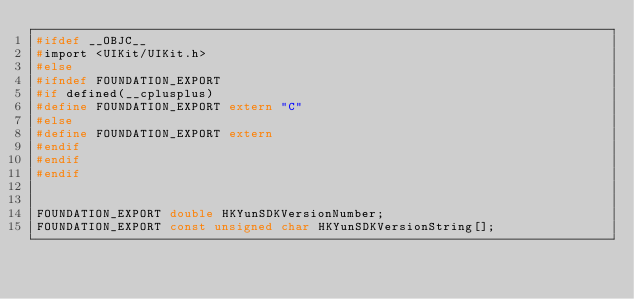Convert code to text. <code><loc_0><loc_0><loc_500><loc_500><_C_>#ifdef __OBJC__
#import <UIKit/UIKit.h>
#else
#ifndef FOUNDATION_EXPORT
#if defined(__cplusplus)
#define FOUNDATION_EXPORT extern "C"
#else
#define FOUNDATION_EXPORT extern
#endif
#endif
#endif


FOUNDATION_EXPORT double HKYunSDKVersionNumber;
FOUNDATION_EXPORT const unsigned char HKYunSDKVersionString[];

</code> 